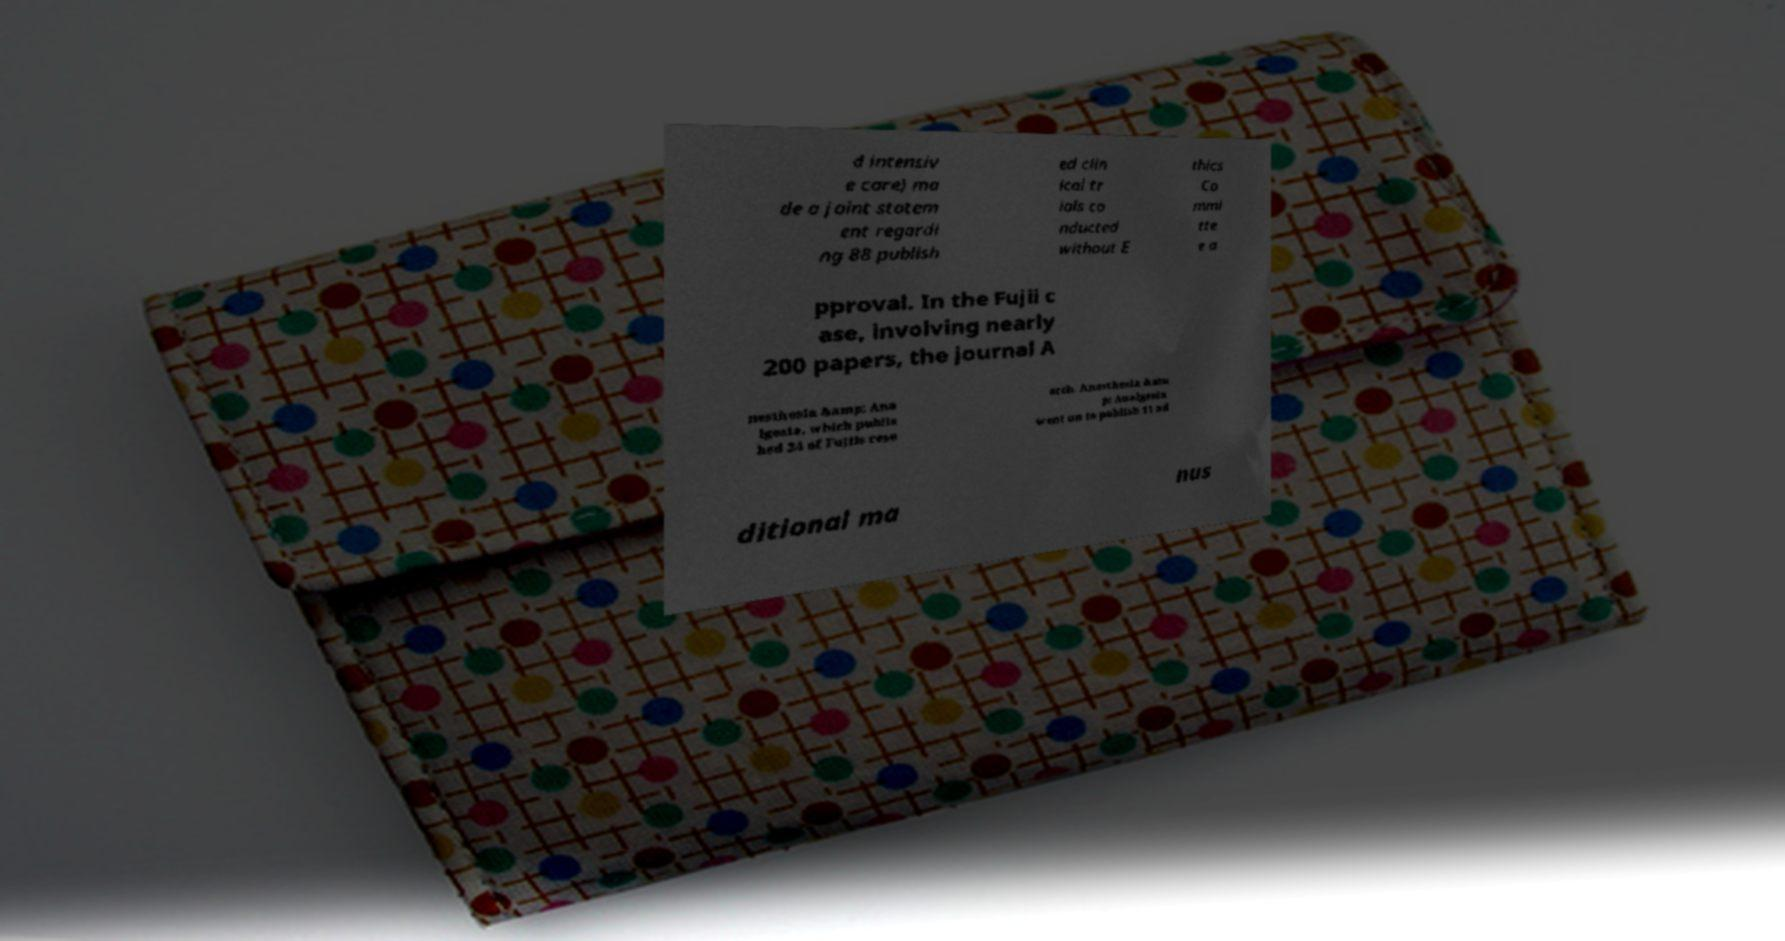For documentation purposes, I need the text within this image transcribed. Could you provide that? d intensiv e care) ma de a joint statem ent regardi ng 88 publish ed clin ical tr ials co nducted without E thics Co mmi tte e a pproval. In the Fujii c ase, involving nearly 200 papers, the journal A nesthesia &amp; Ana lgesia, which publis hed 24 of Fujiis rese arch. Anesthesia &am p; Analgesia went on to publish 11 ad ditional ma nus 